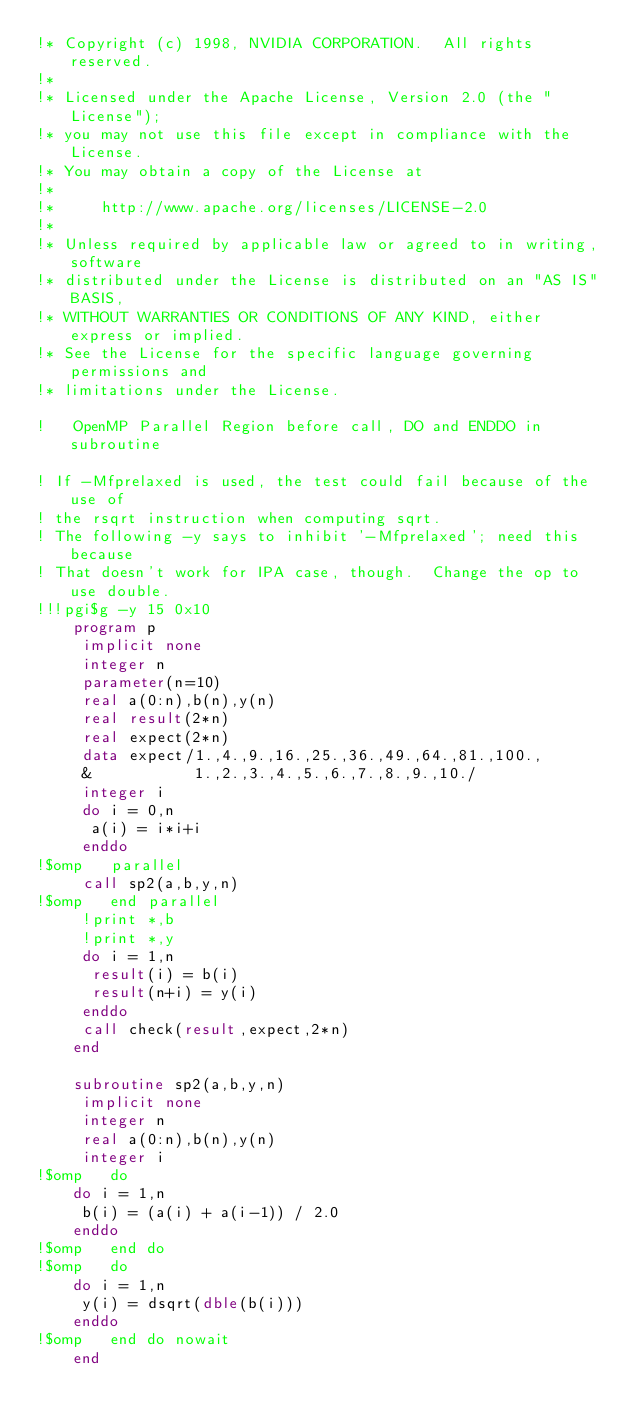Convert code to text. <code><loc_0><loc_0><loc_500><loc_500><_FORTRAN_>!* Copyright (c) 1998, NVIDIA CORPORATION.  All rights reserved.
!*
!* Licensed under the Apache License, Version 2.0 (the "License");
!* you may not use this file except in compliance with the License.
!* You may obtain a copy of the License at
!*
!*     http://www.apache.org/licenses/LICENSE-2.0
!*
!* Unless required by applicable law or agreed to in writing, software
!* distributed under the License is distributed on an "AS IS" BASIS,
!* WITHOUT WARRANTIES OR CONDITIONS OF ANY KIND, either express or implied.
!* See the License for the specific language governing permissions and
!* limitations under the License.

!	OpenMP Parallel Region before call, DO and ENDDO in subroutine

! If -Mfprelaxed is used, the test could fail because of the use of
! the rsqrt instruction when computing sqrt.
! The following -y says to inhibit '-Mfprelaxed'; need this because
! That doesn't work for IPA case, though.  Change the op to use double.
!!!pgi$g -y 15 0x10
	program p
	 implicit none
	 integer n
	 parameter(n=10)
	 real a(0:n),b(n),y(n)
	 real result(2*n)
	 real expect(2*n)
	 data expect/1.,4.,9.,16.,25.,36.,49.,64.,81.,100.,
     &		     1.,2.,3.,4.,5.,6.,7.,8.,9.,10./
	 integer i
	 do i = 0,n
	  a(i) = i*i+i
	 enddo
!$omp   parallel
	 call sp2(a,b,y,n)
!$omp   end parallel
	 !print *,b
	 !print *,y
	 do i = 1,n
	  result(i) = b(i)
	  result(n+i) = y(i)
	 enddo
	 call check(result,expect,2*n)
	end

	subroutine sp2(a,b,y,n)
	 implicit none
	 integer n
	 real a(0:n),b(n),y(n)
	 integer i
!$omp   do
	do i = 1,n
	 b(i) = (a(i) + a(i-1)) / 2.0
	enddo
!$omp   end do 
!$omp   do
	do i = 1,n
	 y(i) = dsqrt(dble(b(i)))
	enddo
!$omp   end do nowait
	end
</code> 